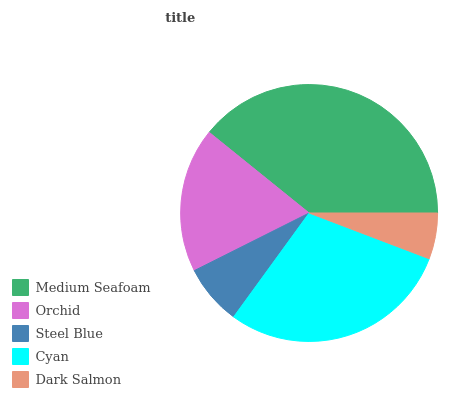Is Dark Salmon the minimum?
Answer yes or no. Yes. Is Medium Seafoam the maximum?
Answer yes or no. Yes. Is Orchid the minimum?
Answer yes or no. No. Is Orchid the maximum?
Answer yes or no. No. Is Medium Seafoam greater than Orchid?
Answer yes or no. Yes. Is Orchid less than Medium Seafoam?
Answer yes or no. Yes. Is Orchid greater than Medium Seafoam?
Answer yes or no. No. Is Medium Seafoam less than Orchid?
Answer yes or no. No. Is Orchid the high median?
Answer yes or no. Yes. Is Orchid the low median?
Answer yes or no. Yes. Is Cyan the high median?
Answer yes or no. No. Is Medium Seafoam the low median?
Answer yes or no. No. 